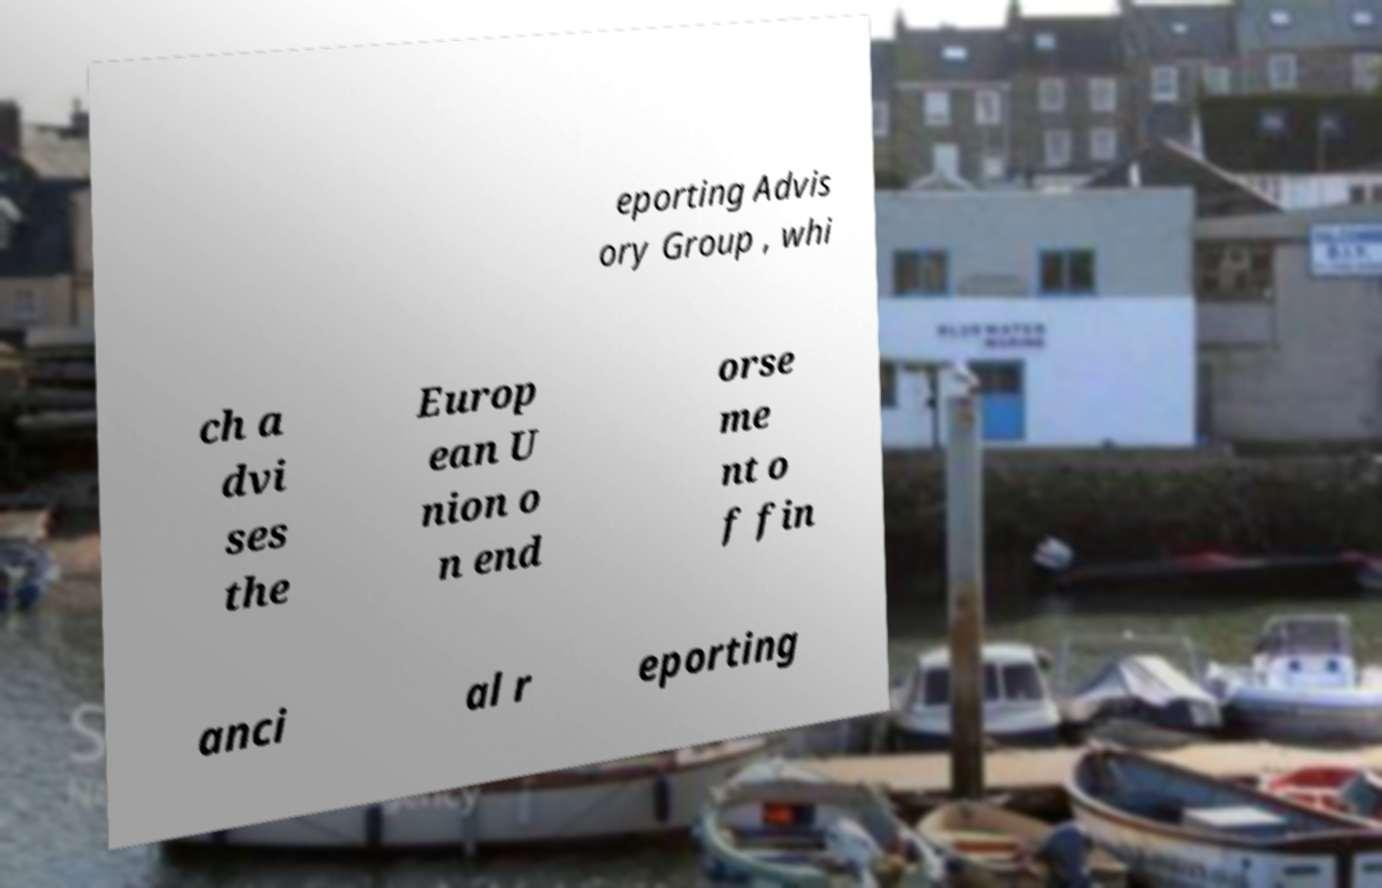Can you read and provide the text displayed in the image?This photo seems to have some interesting text. Can you extract and type it out for me? eporting Advis ory Group , whi ch a dvi ses the Europ ean U nion o n end orse me nt o f fin anci al r eporting 